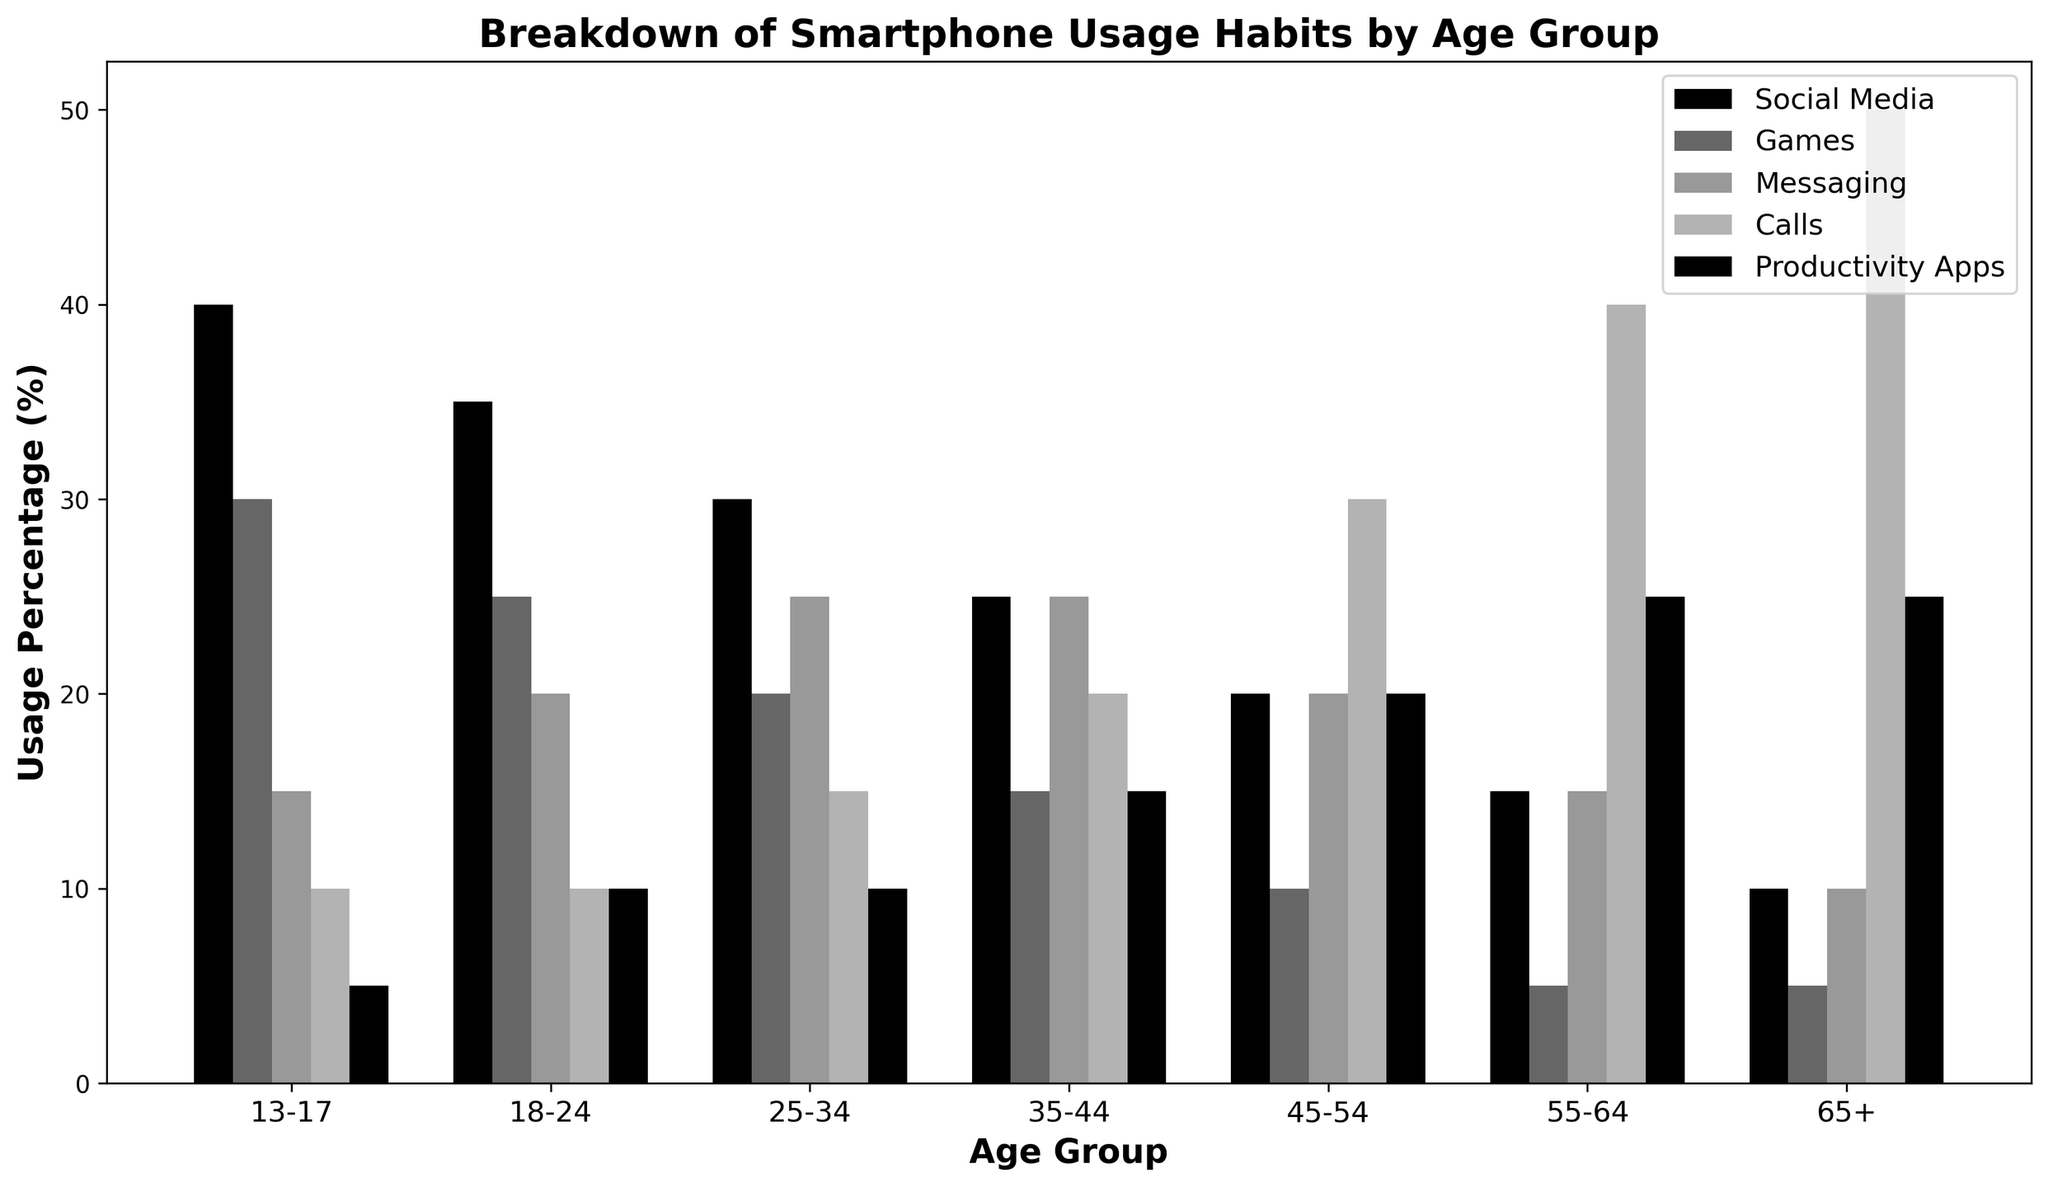What's the most common smartphone usage habit for the 35-44 age group? Look at the bars for the 35-44 age group and see which one is the tallest. The tallest bar represents the most common habit.
Answer: Messaging Which age group spends the most time on productivity apps? Look at the height of the bars corresponding to productivity apps for each age group. The age group with the tallest bar spends the most time on productivity apps.
Answer: 65+ Which age group has the smallest percentage of social media usage? Compare the bars for social media usage across all age groups to see which one is the shortest.
Answer: 65+ What is the combined percentage of calls and games usage for the 18-24 age group? Look at the height of the bars for calls and games in the 18-24 age group, and then add them together. Calls: 10%, Games: 25%, so 10 + 25 = 35%.
Answer: 35% Between the 45-54 and 55-64 age groups, which one uses messaging apps more? Compare the bars representing messaging apps usage for the 45-54 and 55-64 age groups, and see which one is taller.
Answer: 45-54 Which age group has the largest percentage difference between social media and calls usage? Calculate the difference between the social media and calls usage bars for each age group. The age group with the largest difference has the largest percentage difference. For 13-17, difference type value: 40% (social media) - 10% (calls) = 30%. Doing comparisons for all, we find that 13-17 has the largest difference.
Answer: 13-17 How much higher is the percentage of social media usage in the 25-34 age group compared to the 45-54 age group? Subtract the percentage of social media usage in the 45-54 age group from that in the 25-34 age group. 30% (25-34) - 20% (45-54) = 10%.
Answer: 10% If you combine messaging and productivity app usage for the 13-17 and 55-64 age groups, which group has a higher combined percentage? Add the percentage of messaging and productivity app usage for both age groups and compare. For 13-17: 15% (messaging) + 5% (productivity) = 20%. For 55-64: 15% (messaging) + 25% (productivity) = 40%.
Answer: 55-64 What's the average percentage usage of games across all age groups? Add the percentages of game usage for all age groups and then divide by the number of age groups. (30 + 25 + 20 + 15 + 10 + 5 + 5) / 7 =  16.42.
Answer: 16.42 Which age group has an equal percentage usage for social media and calls? Look for the age group where the bars for social media and calls are of the same height.
Answer: 65+ 